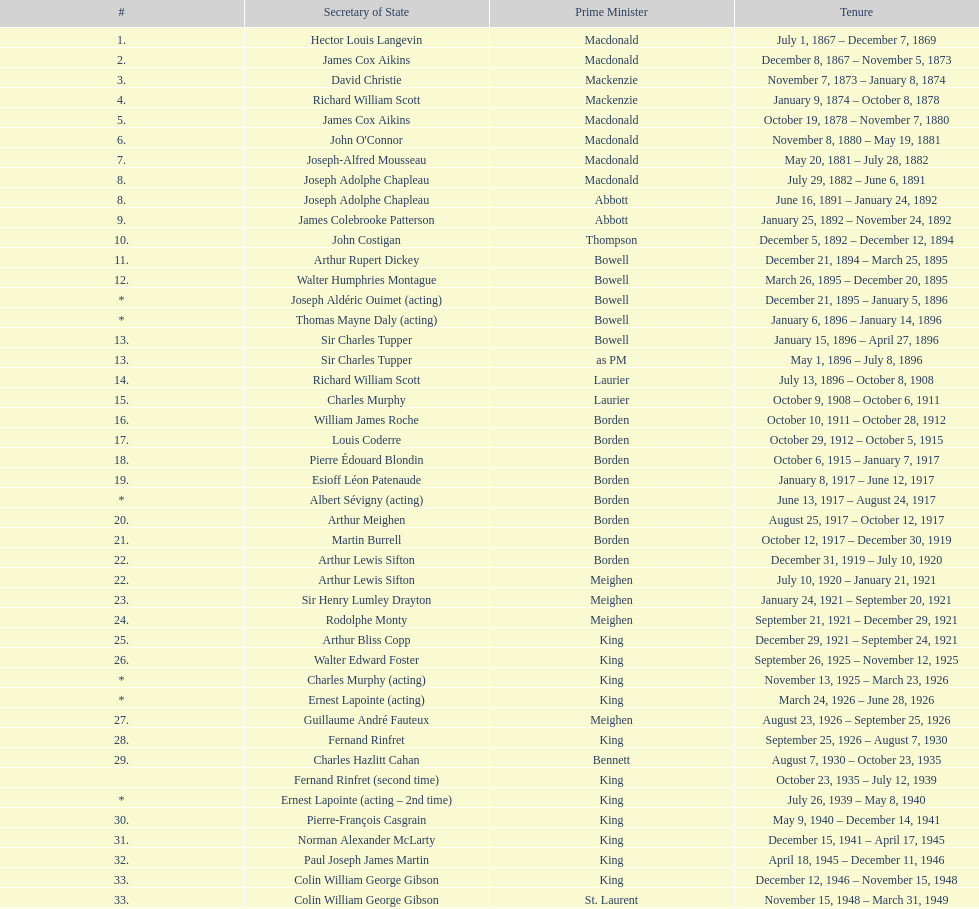What secretary of state served under both prime minister laurier and prime minister king? Charles Murphy. 